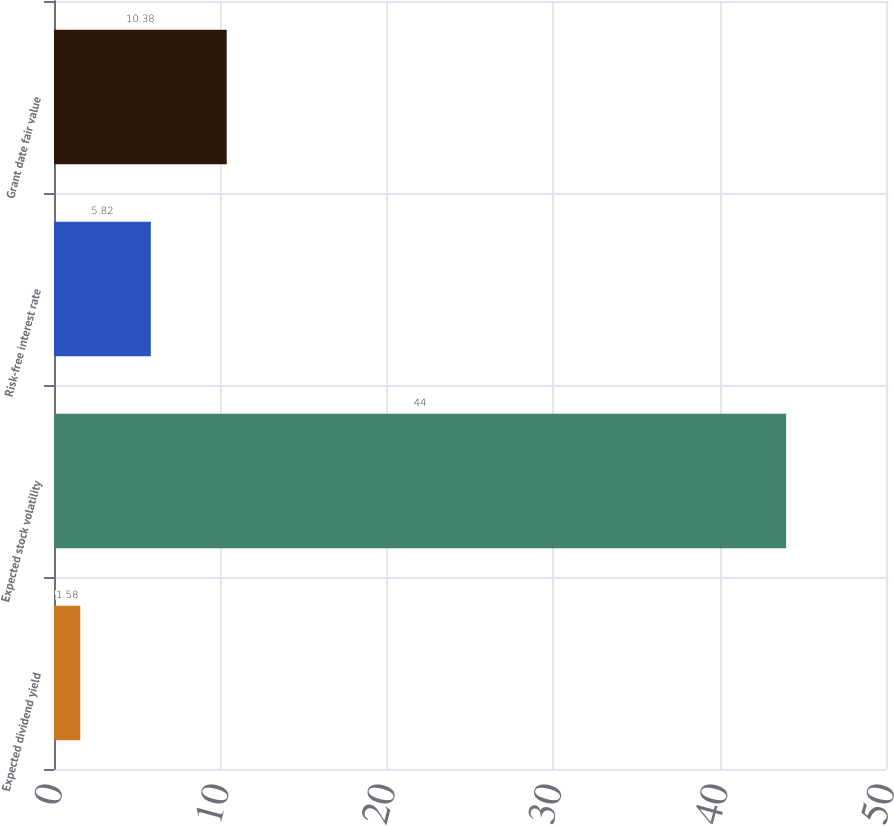Convert chart to OTSL. <chart><loc_0><loc_0><loc_500><loc_500><bar_chart><fcel>Expected dividend yield<fcel>Expected stock volatility<fcel>Risk-free interest rate<fcel>Grant date fair value<nl><fcel>1.58<fcel>44<fcel>5.82<fcel>10.38<nl></chart> 